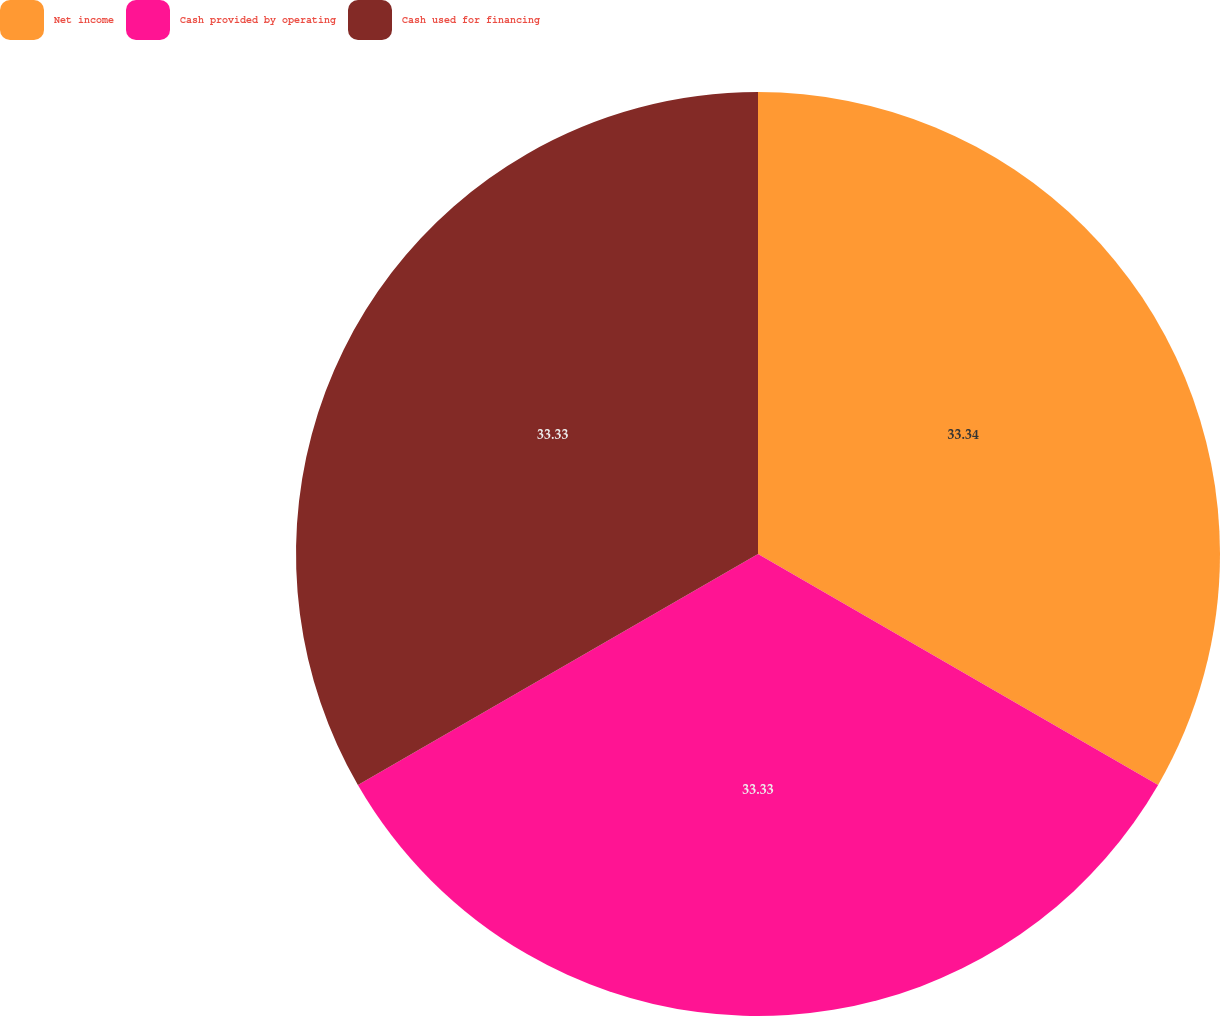Convert chart. <chart><loc_0><loc_0><loc_500><loc_500><pie_chart><fcel>Net income<fcel>Cash provided by operating<fcel>Cash used for financing<nl><fcel>33.33%<fcel>33.33%<fcel>33.33%<nl></chart> 